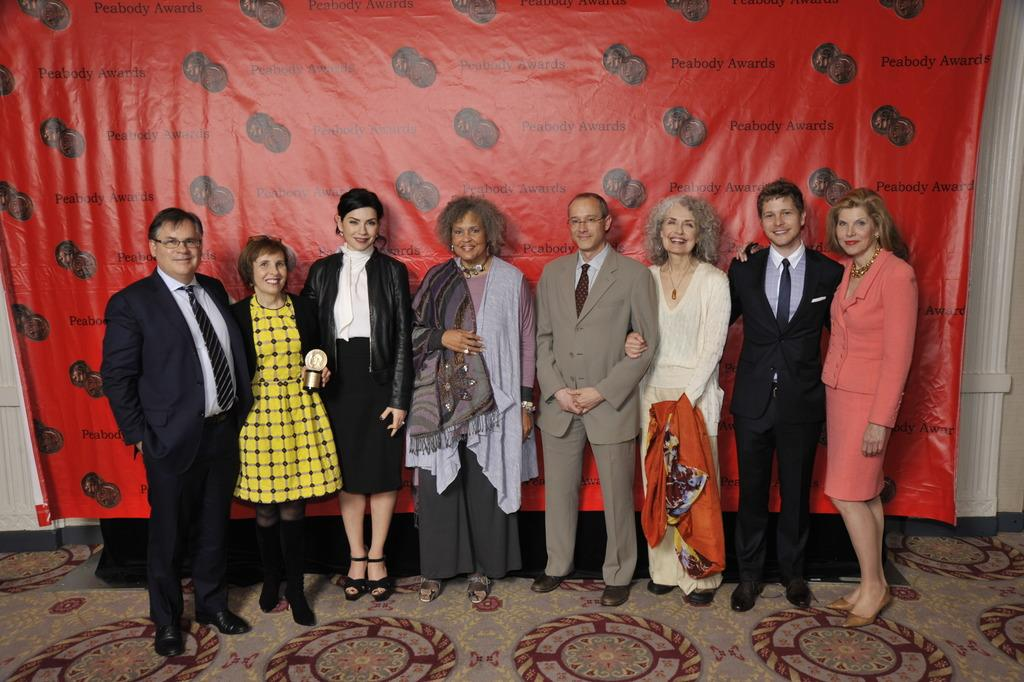What can be seen in the image? There are people standing in the image. What is at the bottom of the image? There is a carpet at the bottom of the image. What is in the background of the image? There is a banner with text in the background of the image. How many trains can be seen in the image? There are no trains present in the image. What story is being told by the people in the image? The image does not convey a specific story; it simply shows people standing. 